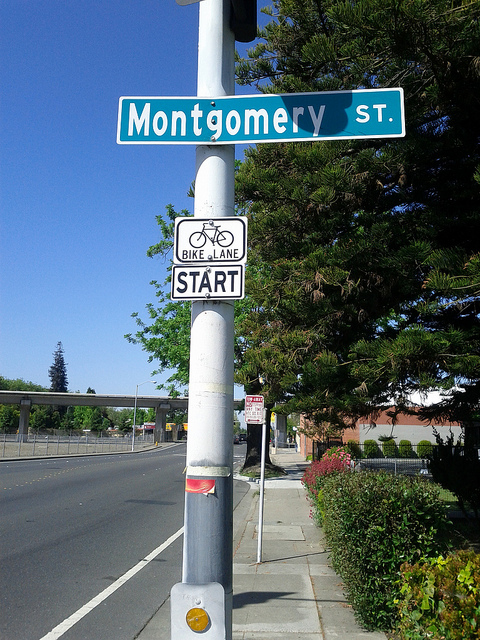Please extract the text content from this image. Montgomery ST BIKE LANE START 